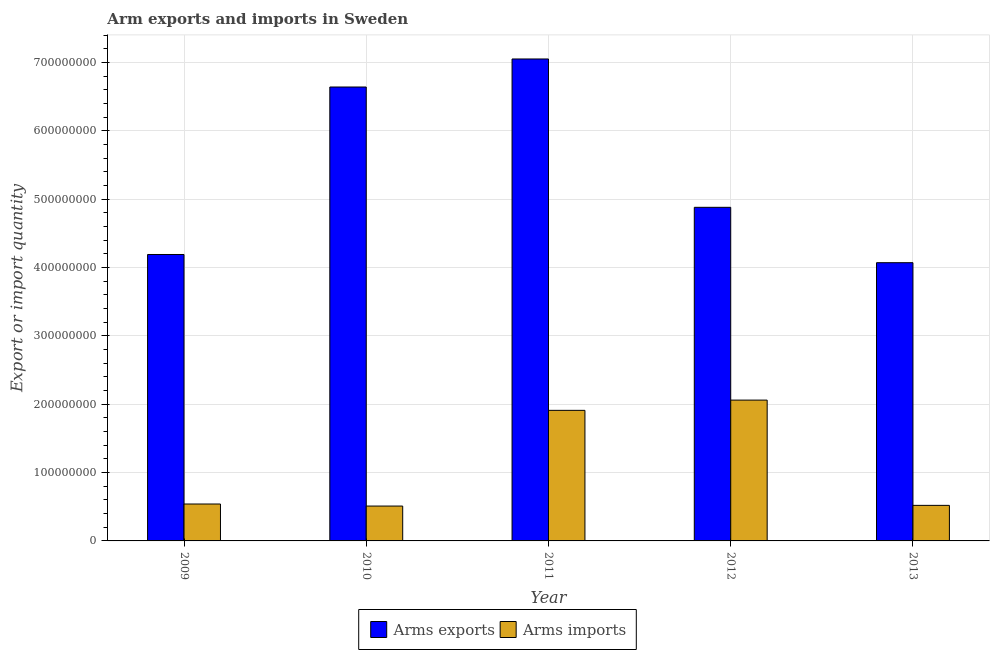How many different coloured bars are there?
Give a very brief answer. 2. Are the number of bars per tick equal to the number of legend labels?
Give a very brief answer. Yes. Are the number of bars on each tick of the X-axis equal?
Your response must be concise. Yes. How many bars are there on the 5th tick from the left?
Your answer should be compact. 2. How many bars are there on the 4th tick from the right?
Offer a terse response. 2. What is the label of the 5th group of bars from the left?
Offer a very short reply. 2013. What is the arms exports in 2013?
Offer a terse response. 4.07e+08. Across all years, what is the maximum arms exports?
Your answer should be compact. 7.05e+08. Across all years, what is the minimum arms imports?
Offer a terse response. 5.10e+07. In which year was the arms imports maximum?
Ensure brevity in your answer.  2012. In which year was the arms imports minimum?
Ensure brevity in your answer.  2010. What is the total arms imports in the graph?
Your response must be concise. 5.54e+08. What is the difference between the arms imports in 2010 and that in 2013?
Your response must be concise. -1.00e+06. What is the difference between the arms imports in 2013 and the arms exports in 2012?
Offer a terse response. -1.54e+08. What is the average arms exports per year?
Keep it short and to the point. 5.37e+08. In the year 2009, what is the difference between the arms exports and arms imports?
Make the answer very short. 0. In how many years, is the arms imports greater than 160000000?
Provide a short and direct response. 2. What is the ratio of the arms exports in 2009 to that in 2012?
Provide a short and direct response. 0.86. What is the difference between the highest and the second highest arms imports?
Provide a succinct answer. 1.50e+07. What is the difference between the highest and the lowest arms imports?
Ensure brevity in your answer.  1.55e+08. In how many years, is the arms imports greater than the average arms imports taken over all years?
Your response must be concise. 2. What does the 2nd bar from the left in 2013 represents?
Give a very brief answer. Arms imports. What does the 1st bar from the right in 2012 represents?
Keep it short and to the point. Arms imports. Are all the bars in the graph horizontal?
Your answer should be compact. No. What is the difference between two consecutive major ticks on the Y-axis?
Offer a very short reply. 1.00e+08. Does the graph contain any zero values?
Ensure brevity in your answer.  No. Where does the legend appear in the graph?
Make the answer very short. Bottom center. How many legend labels are there?
Offer a terse response. 2. What is the title of the graph?
Give a very brief answer. Arm exports and imports in Sweden. Does "State government" appear as one of the legend labels in the graph?
Provide a short and direct response. No. What is the label or title of the Y-axis?
Provide a succinct answer. Export or import quantity. What is the Export or import quantity of Arms exports in 2009?
Keep it short and to the point. 4.19e+08. What is the Export or import quantity in Arms imports in 2009?
Provide a succinct answer. 5.40e+07. What is the Export or import quantity in Arms exports in 2010?
Your answer should be very brief. 6.64e+08. What is the Export or import quantity of Arms imports in 2010?
Give a very brief answer. 5.10e+07. What is the Export or import quantity in Arms exports in 2011?
Make the answer very short. 7.05e+08. What is the Export or import quantity in Arms imports in 2011?
Make the answer very short. 1.91e+08. What is the Export or import quantity in Arms exports in 2012?
Make the answer very short. 4.88e+08. What is the Export or import quantity in Arms imports in 2012?
Offer a very short reply. 2.06e+08. What is the Export or import quantity of Arms exports in 2013?
Your answer should be very brief. 4.07e+08. What is the Export or import quantity of Arms imports in 2013?
Provide a short and direct response. 5.20e+07. Across all years, what is the maximum Export or import quantity in Arms exports?
Provide a short and direct response. 7.05e+08. Across all years, what is the maximum Export or import quantity in Arms imports?
Offer a very short reply. 2.06e+08. Across all years, what is the minimum Export or import quantity in Arms exports?
Make the answer very short. 4.07e+08. Across all years, what is the minimum Export or import quantity of Arms imports?
Ensure brevity in your answer.  5.10e+07. What is the total Export or import quantity of Arms exports in the graph?
Offer a terse response. 2.68e+09. What is the total Export or import quantity of Arms imports in the graph?
Offer a very short reply. 5.54e+08. What is the difference between the Export or import quantity of Arms exports in 2009 and that in 2010?
Offer a terse response. -2.45e+08. What is the difference between the Export or import quantity in Arms exports in 2009 and that in 2011?
Offer a terse response. -2.86e+08. What is the difference between the Export or import quantity in Arms imports in 2009 and that in 2011?
Your answer should be compact. -1.37e+08. What is the difference between the Export or import quantity of Arms exports in 2009 and that in 2012?
Give a very brief answer. -6.90e+07. What is the difference between the Export or import quantity in Arms imports in 2009 and that in 2012?
Your answer should be compact. -1.52e+08. What is the difference between the Export or import quantity in Arms exports in 2009 and that in 2013?
Your answer should be very brief. 1.20e+07. What is the difference between the Export or import quantity of Arms exports in 2010 and that in 2011?
Provide a short and direct response. -4.10e+07. What is the difference between the Export or import quantity in Arms imports in 2010 and that in 2011?
Give a very brief answer. -1.40e+08. What is the difference between the Export or import quantity in Arms exports in 2010 and that in 2012?
Keep it short and to the point. 1.76e+08. What is the difference between the Export or import quantity of Arms imports in 2010 and that in 2012?
Provide a short and direct response. -1.55e+08. What is the difference between the Export or import quantity of Arms exports in 2010 and that in 2013?
Keep it short and to the point. 2.57e+08. What is the difference between the Export or import quantity in Arms exports in 2011 and that in 2012?
Give a very brief answer. 2.17e+08. What is the difference between the Export or import quantity in Arms imports in 2011 and that in 2012?
Ensure brevity in your answer.  -1.50e+07. What is the difference between the Export or import quantity in Arms exports in 2011 and that in 2013?
Provide a short and direct response. 2.98e+08. What is the difference between the Export or import quantity in Arms imports in 2011 and that in 2013?
Keep it short and to the point. 1.39e+08. What is the difference between the Export or import quantity of Arms exports in 2012 and that in 2013?
Give a very brief answer. 8.10e+07. What is the difference between the Export or import quantity of Arms imports in 2012 and that in 2013?
Ensure brevity in your answer.  1.54e+08. What is the difference between the Export or import quantity in Arms exports in 2009 and the Export or import quantity in Arms imports in 2010?
Your response must be concise. 3.68e+08. What is the difference between the Export or import quantity in Arms exports in 2009 and the Export or import quantity in Arms imports in 2011?
Provide a short and direct response. 2.28e+08. What is the difference between the Export or import quantity of Arms exports in 2009 and the Export or import quantity of Arms imports in 2012?
Offer a terse response. 2.13e+08. What is the difference between the Export or import quantity of Arms exports in 2009 and the Export or import quantity of Arms imports in 2013?
Your response must be concise. 3.67e+08. What is the difference between the Export or import quantity in Arms exports in 2010 and the Export or import quantity in Arms imports in 2011?
Ensure brevity in your answer.  4.73e+08. What is the difference between the Export or import quantity of Arms exports in 2010 and the Export or import quantity of Arms imports in 2012?
Provide a succinct answer. 4.58e+08. What is the difference between the Export or import quantity of Arms exports in 2010 and the Export or import quantity of Arms imports in 2013?
Make the answer very short. 6.12e+08. What is the difference between the Export or import quantity in Arms exports in 2011 and the Export or import quantity in Arms imports in 2012?
Your answer should be very brief. 4.99e+08. What is the difference between the Export or import quantity of Arms exports in 2011 and the Export or import quantity of Arms imports in 2013?
Your response must be concise. 6.53e+08. What is the difference between the Export or import quantity of Arms exports in 2012 and the Export or import quantity of Arms imports in 2013?
Keep it short and to the point. 4.36e+08. What is the average Export or import quantity in Arms exports per year?
Give a very brief answer. 5.37e+08. What is the average Export or import quantity in Arms imports per year?
Offer a terse response. 1.11e+08. In the year 2009, what is the difference between the Export or import quantity in Arms exports and Export or import quantity in Arms imports?
Keep it short and to the point. 3.65e+08. In the year 2010, what is the difference between the Export or import quantity of Arms exports and Export or import quantity of Arms imports?
Offer a terse response. 6.13e+08. In the year 2011, what is the difference between the Export or import quantity of Arms exports and Export or import quantity of Arms imports?
Your response must be concise. 5.14e+08. In the year 2012, what is the difference between the Export or import quantity of Arms exports and Export or import quantity of Arms imports?
Offer a terse response. 2.82e+08. In the year 2013, what is the difference between the Export or import quantity of Arms exports and Export or import quantity of Arms imports?
Offer a terse response. 3.55e+08. What is the ratio of the Export or import quantity in Arms exports in 2009 to that in 2010?
Offer a terse response. 0.63. What is the ratio of the Export or import quantity of Arms imports in 2009 to that in 2010?
Your response must be concise. 1.06. What is the ratio of the Export or import quantity of Arms exports in 2009 to that in 2011?
Keep it short and to the point. 0.59. What is the ratio of the Export or import quantity of Arms imports in 2009 to that in 2011?
Make the answer very short. 0.28. What is the ratio of the Export or import quantity of Arms exports in 2009 to that in 2012?
Provide a succinct answer. 0.86. What is the ratio of the Export or import quantity in Arms imports in 2009 to that in 2012?
Your answer should be very brief. 0.26. What is the ratio of the Export or import quantity in Arms exports in 2009 to that in 2013?
Keep it short and to the point. 1.03. What is the ratio of the Export or import quantity in Arms exports in 2010 to that in 2011?
Keep it short and to the point. 0.94. What is the ratio of the Export or import quantity of Arms imports in 2010 to that in 2011?
Offer a terse response. 0.27. What is the ratio of the Export or import quantity of Arms exports in 2010 to that in 2012?
Ensure brevity in your answer.  1.36. What is the ratio of the Export or import quantity of Arms imports in 2010 to that in 2012?
Your answer should be compact. 0.25. What is the ratio of the Export or import quantity in Arms exports in 2010 to that in 2013?
Offer a terse response. 1.63. What is the ratio of the Export or import quantity in Arms imports in 2010 to that in 2013?
Make the answer very short. 0.98. What is the ratio of the Export or import quantity in Arms exports in 2011 to that in 2012?
Your response must be concise. 1.44. What is the ratio of the Export or import quantity of Arms imports in 2011 to that in 2012?
Make the answer very short. 0.93. What is the ratio of the Export or import quantity of Arms exports in 2011 to that in 2013?
Offer a very short reply. 1.73. What is the ratio of the Export or import quantity in Arms imports in 2011 to that in 2013?
Make the answer very short. 3.67. What is the ratio of the Export or import quantity of Arms exports in 2012 to that in 2013?
Give a very brief answer. 1.2. What is the ratio of the Export or import quantity in Arms imports in 2012 to that in 2013?
Your response must be concise. 3.96. What is the difference between the highest and the second highest Export or import quantity in Arms exports?
Offer a terse response. 4.10e+07. What is the difference between the highest and the second highest Export or import quantity in Arms imports?
Your answer should be compact. 1.50e+07. What is the difference between the highest and the lowest Export or import quantity of Arms exports?
Your response must be concise. 2.98e+08. What is the difference between the highest and the lowest Export or import quantity of Arms imports?
Provide a succinct answer. 1.55e+08. 